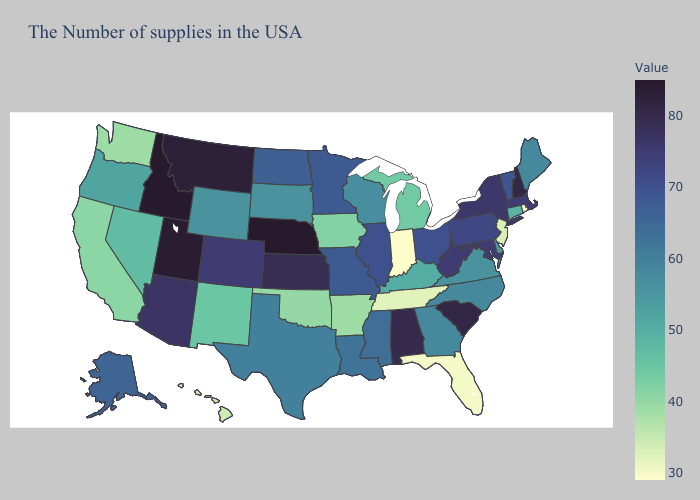Does Nevada have the lowest value in the West?
Concise answer only. No. Does South Carolina have the highest value in the South?
Concise answer only. Yes. Among the states that border New Jersey , which have the highest value?
Give a very brief answer. New York. Which states have the lowest value in the USA?
Quick response, please. Indiana. Among the states that border Kentucky , which have the lowest value?
Write a very short answer. Indiana. Does Connecticut have the highest value in the Northeast?
Write a very short answer. No. Among the states that border Minnesota , does South Dakota have the lowest value?
Be succinct. No. Which states have the highest value in the USA?
Short answer required. Nebraska, Idaho. Which states have the lowest value in the USA?
Quick response, please. Indiana. 